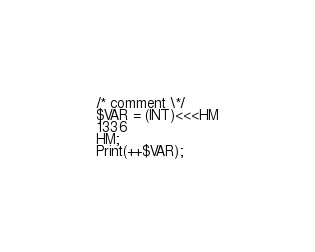Convert code to text. <code><loc_0><loc_0><loc_500><loc_500><_PHP_>/* comment \*/
$VAR = (INT)<<<HM
1336
HM;
Print(++$VAR);
</code> 